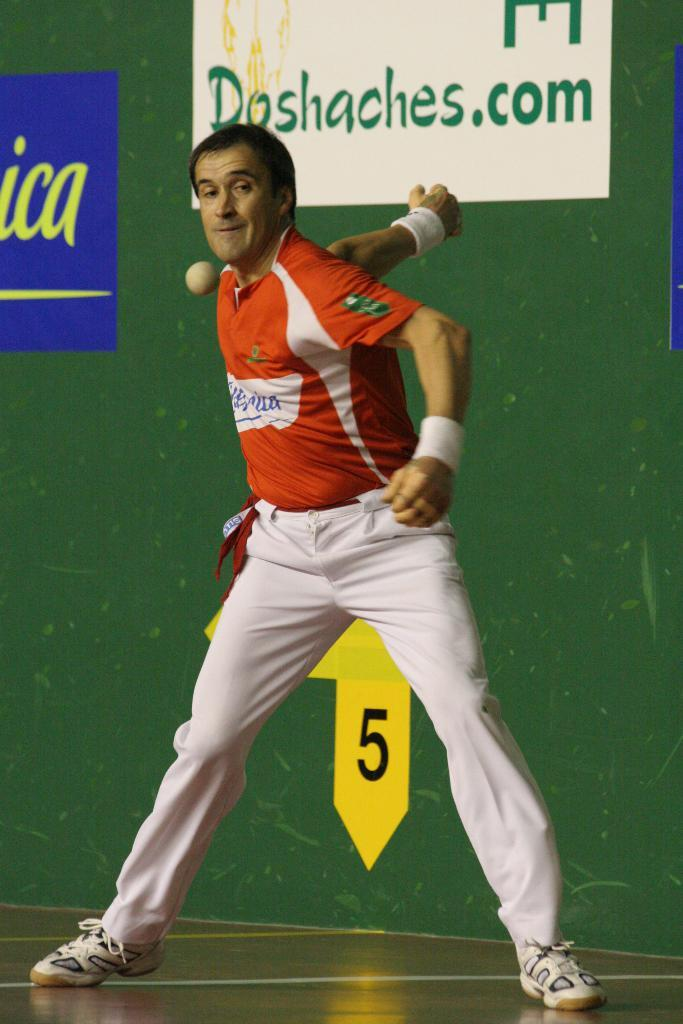<image>
Share a concise interpretation of the image provided. A player of a game with a sign behind him that says Doshaches.com 